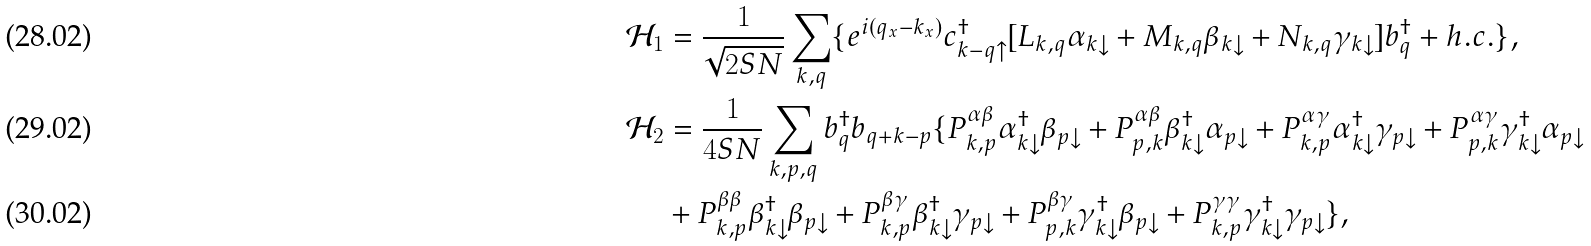Convert formula to latex. <formula><loc_0><loc_0><loc_500><loc_500>\mathcal { H } _ { 1 } & = \frac { 1 } { \sqrt { 2 S N } } \sum _ { k , q } \{ e ^ { i ( q _ { x } - k _ { x } ) } c _ { k - q \uparrow } ^ { \dagger } [ L _ { k , q } \alpha _ { k \downarrow } + M _ { k , q } \beta _ { k \downarrow } + N _ { k , q } \gamma _ { k \downarrow } ] b _ { q } ^ { \dagger } + h . c . \} , \\ \mathcal { H } _ { 2 } & = \frac { 1 } { 4 S N } \sum _ { k , p , q } b _ { q } ^ { \dagger } b _ { q + k - p } \{ P _ { k , p } ^ { \alpha \beta } \alpha _ { k \downarrow } ^ { \dagger } \beta _ { p \downarrow } + P _ { p , k } ^ { \alpha \beta } \beta _ { k \downarrow } ^ { \dagger } \alpha _ { p \downarrow } + P _ { k , p } ^ { \alpha \gamma } \alpha _ { k \downarrow } ^ { \dagger } \gamma _ { p \downarrow } + P _ { p , k } ^ { \alpha \gamma } \gamma _ { k \downarrow } ^ { \dagger } \alpha _ { p \downarrow } \\ & + P _ { k , p } ^ { \beta \beta } \beta _ { k \downarrow } ^ { \dagger } \beta _ { p \downarrow } + P _ { k , p } ^ { \beta \gamma } \beta _ { k \downarrow } ^ { \dagger } \gamma _ { p \downarrow } + P _ { p , k } ^ { \beta \gamma } \gamma _ { k \downarrow } ^ { \dagger } \beta _ { p \downarrow } + P _ { k , p } ^ { \gamma \gamma } \gamma _ { k \downarrow } ^ { \dagger } \gamma _ { p \downarrow } \} ,</formula> 